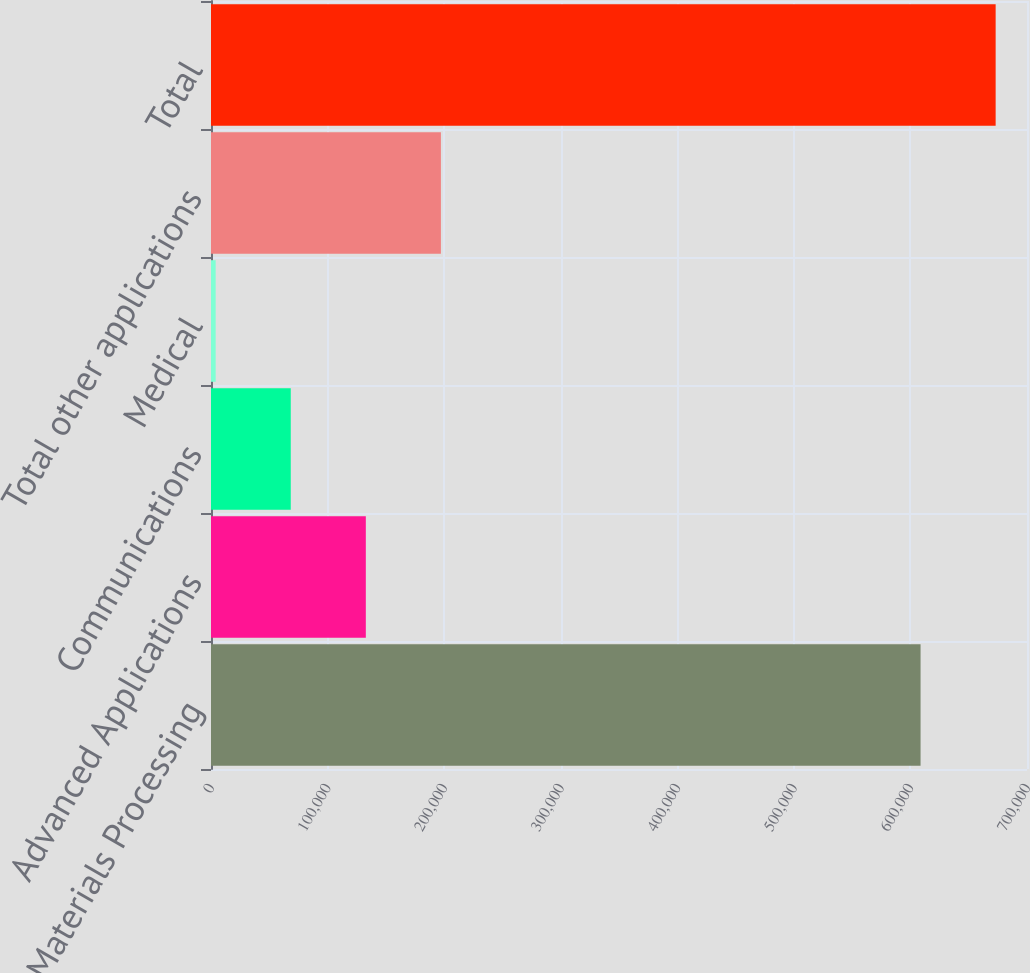Convert chart to OTSL. <chart><loc_0><loc_0><loc_500><loc_500><bar_chart><fcel>Materials Processing<fcel>Advanced Applications<fcel>Communications<fcel>Medical<fcel>Total other applications<fcel>Total<nl><fcel>608702<fcel>132812<fcel>68409.7<fcel>4007<fcel>197215<fcel>673105<nl></chart> 